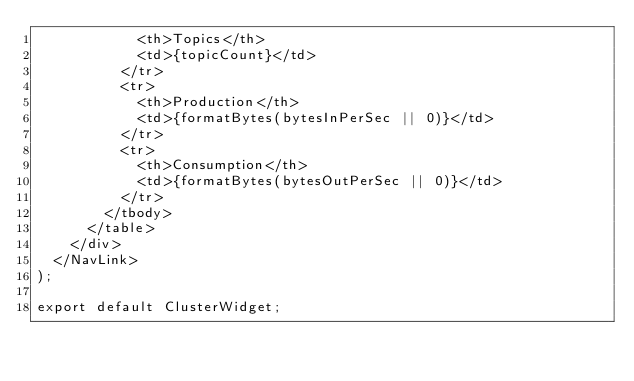<code> <loc_0><loc_0><loc_500><loc_500><_TypeScript_>            <th>Topics</th>
            <td>{topicCount}</td>
          </tr>
          <tr>
            <th>Production</th>
            <td>{formatBytes(bytesInPerSec || 0)}</td>
          </tr>
          <tr>
            <th>Consumption</th>
            <td>{formatBytes(bytesOutPerSec || 0)}</td>
          </tr>
        </tbody>
      </table>
    </div>
  </NavLink>
);

export default ClusterWidget;
</code> 